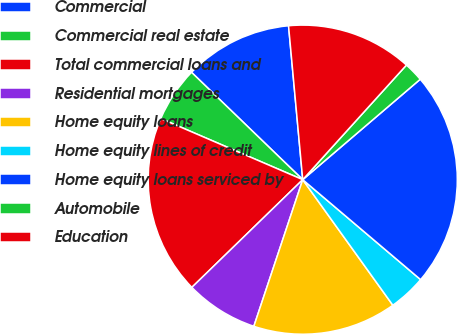Convert chart to OTSL. <chart><loc_0><loc_0><loc_500><loc_500><pie_chart><fcel>Commercial<fcel>Commercial real estate<fcel>Total commercial loans and<fcel>Residential mortgages<fcel>Home equity loans<fcel>Home equity lines of credit<fcel>Home equity loans serviced by<fcel>Automobile<fcel>Education<nl><fcel>11.32%<fcel>5.75%<fcel>18.74%<fcel>7.61%<fcel>15.03%<fcel>3.9%<fcel>22.45%<fcel>2.04%<fcel>13.17%<nl></chart> 